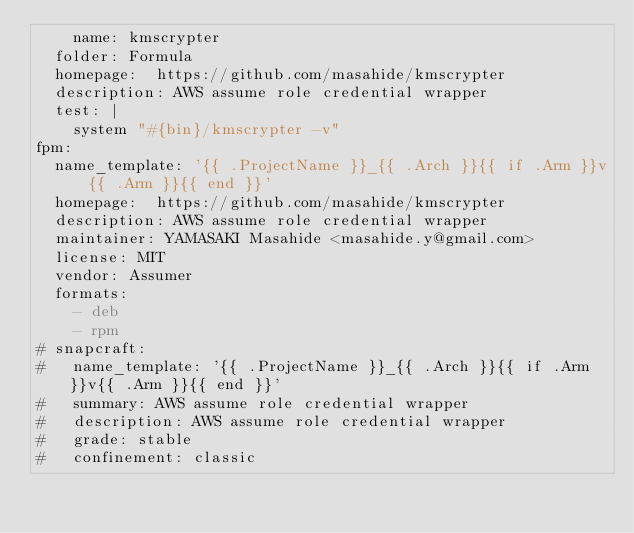Convert code to text. <code><loc_0><loc_0><loc_500><loc_500><_YAML_>    name: kmscrypter
  folder: Formula
  homepage:  https://github.com/masahide/kmscrypter
  description: AWS assume role credential wrapper
  test: |
    system "#{bin}/kmscrypter -v"
fpm:
  name_template: '{{ .ProjectName }}_{{ .Arch }}{{ if .Arm }}v{{ .Arm }}{{ end }}'
  homepage:  https://github.com/masahide/kmscrypter
  description: AWS assume role credential wrapper
  maintainer: YAMASAKI Masahide <masahide.y@gmail.com>
  license: MIT
  vendor: Assumer
  formats:
    - deb
    - rpm
# snapcraft:
#   name_template: '{{ .ProjectName }}_{{ .Arch }}{{ if .Arm }}v{{ .Arm }}{{ end }}'
#   summary: AWS assume role credential wrapper
#   description: AWS assume role credential wrapper
#   grade: stable
#   confinement: classic
</code> 